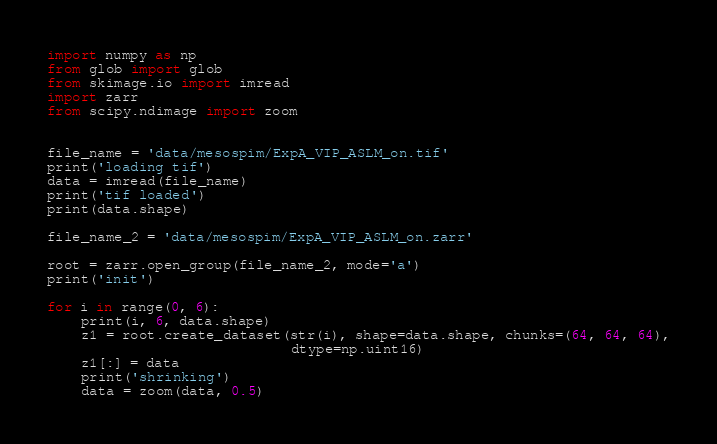Convert code to text. <code><loc_0><loc_0><loc_500><loc_500><_Python_>import numpy as np
from glob import glob
from skimage.io import imread
import zarr
from scipy.ndimage import zoom


file_name = 'data/mesospim/ExpA_VIP_ASLM_on.tif'
print('loading tif')
data = imread(file_name)
print('tif loaded')
print(data.shape)

file_name_2 = 'data/mesospim/ExpA_VIP_ASLM_on.zarr'

root = zarr.open_group(file_name_2, mode='a')
print('init')

for i in range(0, 6):
    print(i, 6, data.shape)
    z1 = root.create_dataset(str(i), shape=data.shape, chunks=(64, 64, 64),
                             dtype=np.uint16)
    z1[:] = data
    print('shrinking')
    data = zoom(data, 0.5)
</code> 